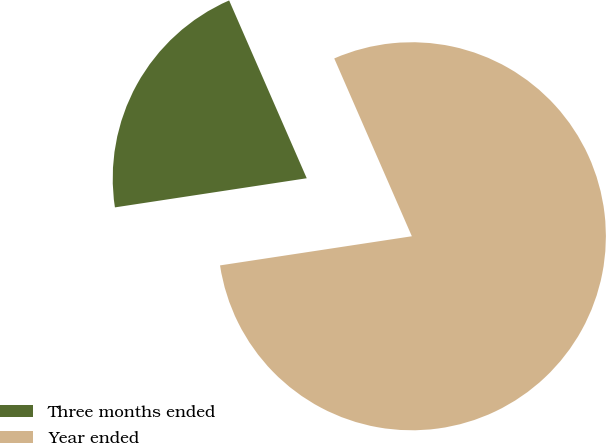<chart> <loc_0><loc_0><loc_500><loc_500><pie_chart><fcel>Three months ended<fcel>Year ended<nl><fcel>20.85%<fcel>79.15%<nl></chart> 